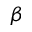<formula> <loc_0><loc_0><loc_500><loc_500>\beta</formula> 